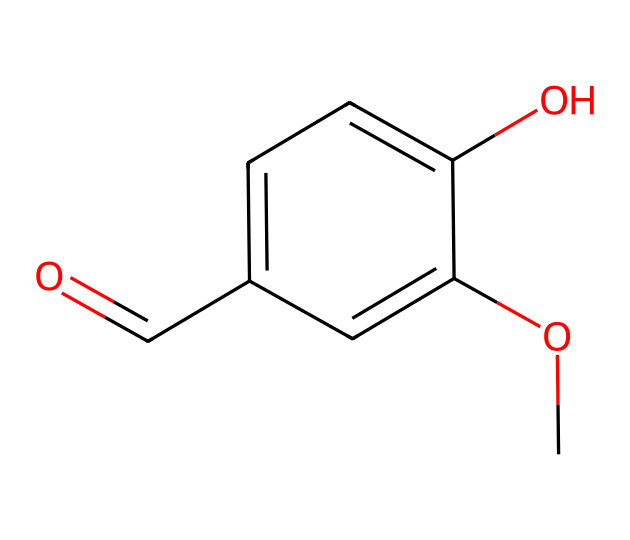What is the molecular formula of this compound? By analyzing the SMILES representation, we can identify the atoms present. The structure consists of 8 carbon (C) atoms, 8 hydrogen (H) atoms, and 3 oxygen (O) atoms. Therefore, the molecular formula is C8H8O3.
Answer: C8H8O3 How many hydroxyl groups (–OH) are present in the molecule? In the provided SMILES structure, there is one –OH group indicated by the "O" that is directly connected to a carbon in the aromatic ring. This makes it clear that there is a single hydroxyl group in this compound.
Answer: 1 Which functional group primarily gives this compound its vanilla flavor? The compound contains a carbonyl group (C=O) as part of an aldehyde functionality, which is a key feature that contributes to the distinctive vanilla flavor.
Answer: carbonyl What type of compound is this molecule classified as? The presence of aromatic rings and functional groups indicates that this compound is classified as a flavor compound, specifically a phenolic compound due to its structural characteristics.
Answer: phenolic Based on the structure, how many double bonds are present? The SMILES representation reveals one double bond in the carbonyl group (C=O) and an additional double bond in the aromatic ring structure. Thus, there are two double bonds in total.
Answer: 2 What is the main source from which this compound is obtained? Vanillin, the compound represented by the SMILES, is primarily sourced from vanilla beans, although it can also be synthesized artificially or derived from lignin.
Answer: vanilla beans 